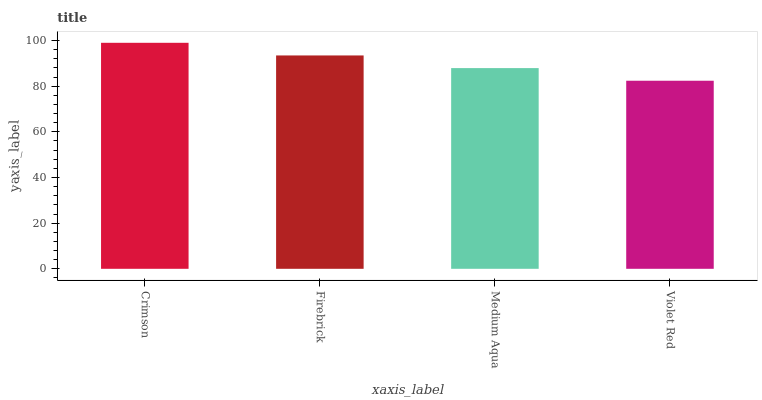Is Violet Red the minimum?
Answer yes or no. Yes. Is Crimson the maximum?
Answer yes or no. Yes. Is Firebrick the minimum?
Answer yes or no. No. Is Firebrick the maximum?
Answer yes or no. No. Is Crimson greater than Firebrick?
Answer yes or no. Yes. Is Firebrick less than Crimson?
Answer yes or no. Yes. Is Firebrick greater than Crimson?
Answer yes or no. No. Is Crimson less than Firebrick?
Answer yes or no. No. Is Firebrick the high median?
Answer yes or no. Yes. Is Medium Aqua the low median?
Answer yes or no. Yes. Is Medium Aqua the high median?
Answer yes or no. No. Is Crimson the low median?
Answer yes or no. No. 